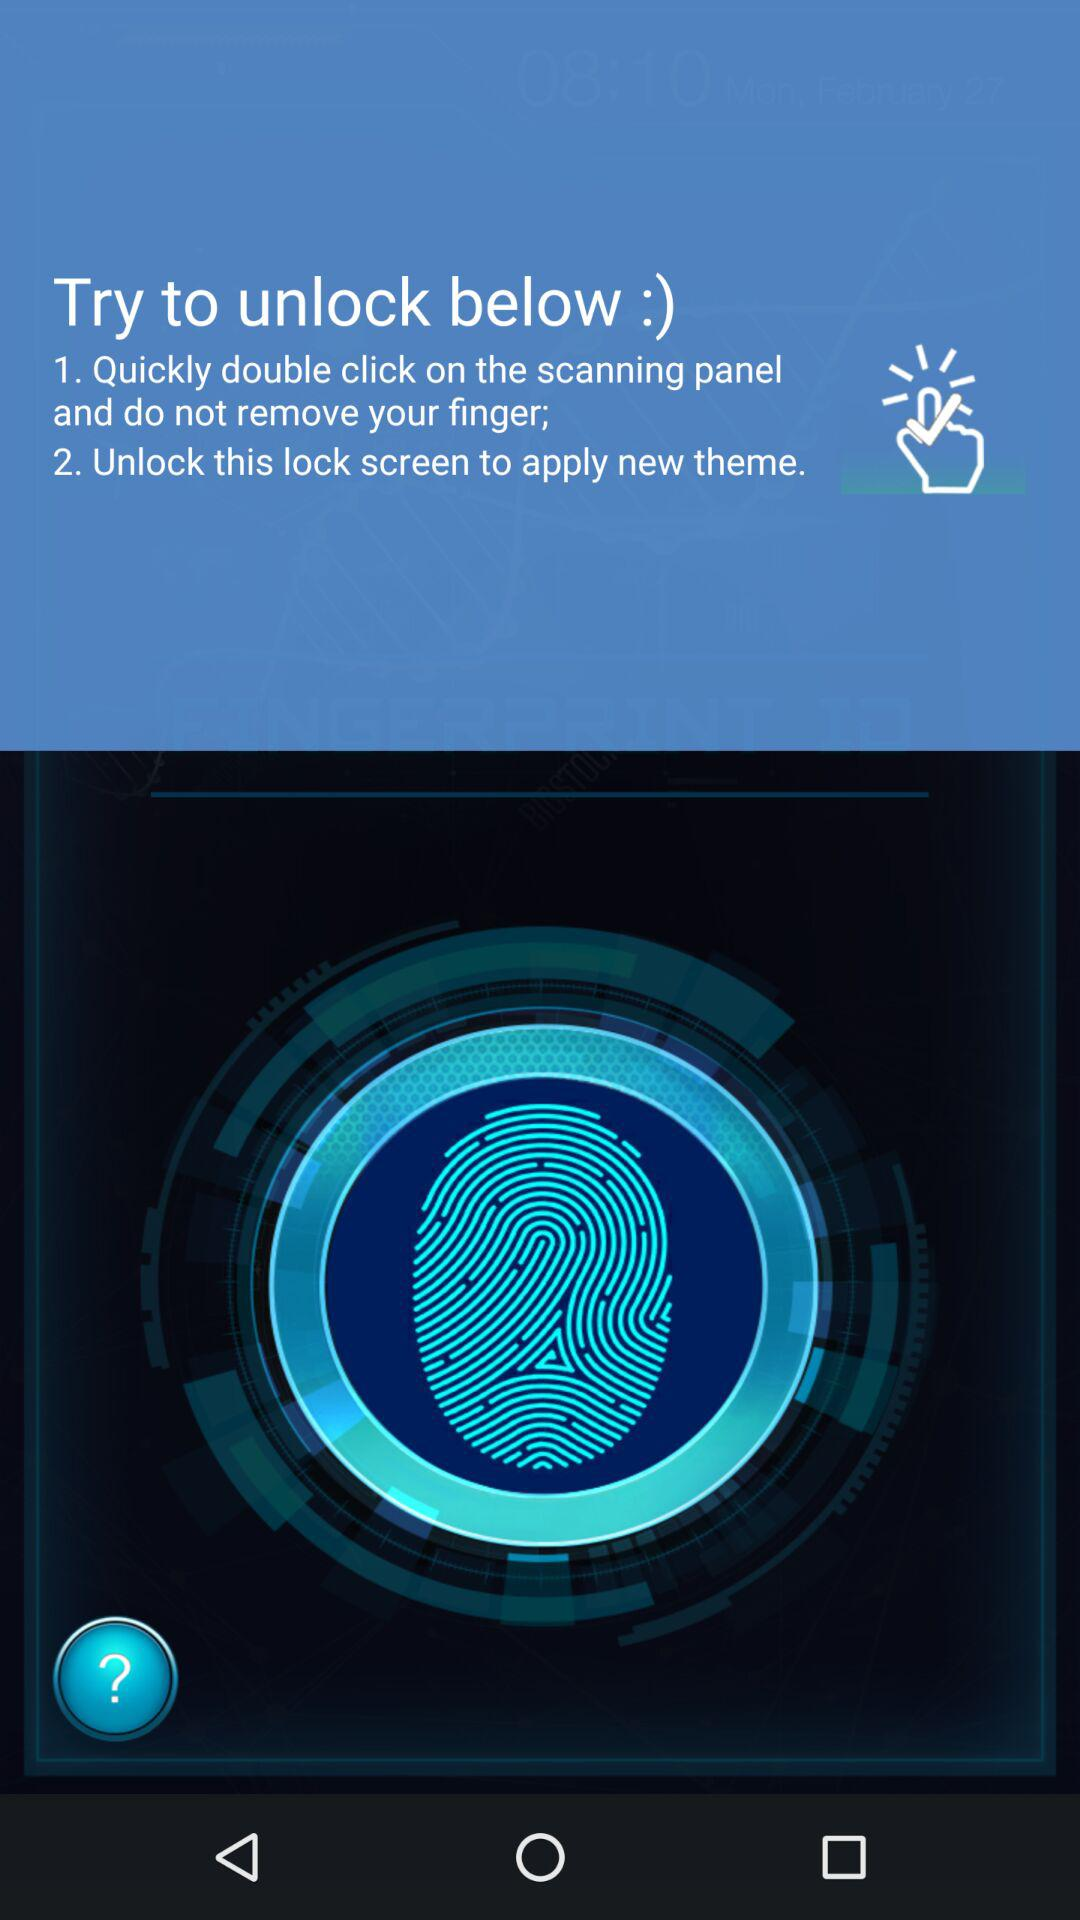What are the steps to unlock? The steps to unlock are "1. Quickly double click on the scanning panel and do not remove your finger" and "2. Unlock this lock screen to apply new theme". 